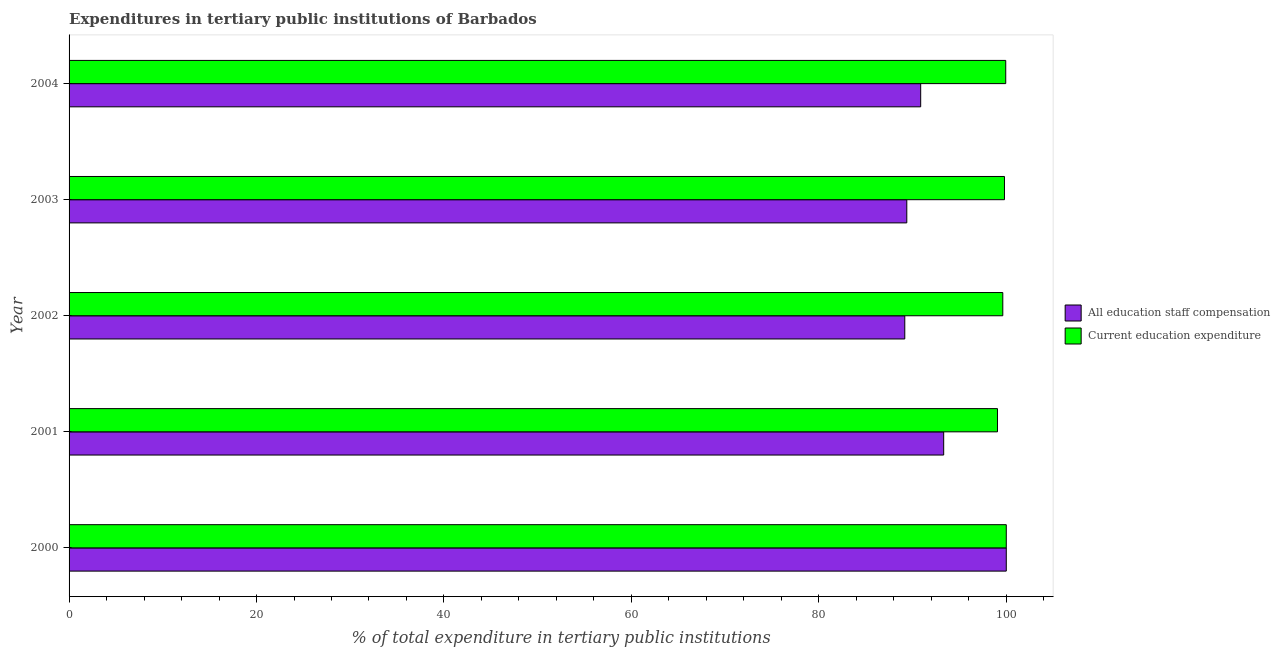How many groups of bars are there?
Make the answer very short. 5. Are the number of bars per tick equal to the number of legend labels?
Make the answer very short. Yes. How many bars are there on the 5th tick from the bottom?
Offer a very short reply. 2. What is the label of the 5th group of bars from the top?
Your response must be concise. 2000. In how many cases, is the number of bars for a given year not equal to the number of legend labels?
Ensure brevity in your answer.  0. What is the expenditure in education in 2000?
Make the answer very short. 100. Across all years, what is the minimum expenditure in staff compensation?
Keep it short and to the point. 89.17. What is the total expenditure in education in the graph?
Your response must be concise. 498.43. What is the difference between the expenditure in education in 2001 and that in 2003?
Ensure brevity in your answer.  -0.74. What is the difference between the expenditure in staff compensation in 2003 and the expenditure in education in 2001?
Your answer should be compact. -9.68. What is the average expenditure in staff compensation per year?
Your response must be concise. 92.55. In the year 2001, what is the difference between the expenditure in staff compensation and expenditure in education?
Give a very brief answer. -5.74. Is the difference between the expenditure in staff compensation in 2003 and 2004 greater than the difference between the expenditure in education in 2003 and 2004?
Offer a terse response. No. What is the difference between the highest and the second highest expenditure in education?
Offer a very short reply. 0.06. What is the difference between the highest and the lowest expenditure in staff compensation?
Your answer should be very brief. 10.83. Is the sum of the expenditure in staff compensation in 2000 and 2001 greater than the maximum expenditure in education across all years?
Your answer should be very brief. Yes. What does the 2nd bar from the top in 2004 represents?
Your answer should be compact. All education staff compensation. What does the 1st bar from the bottom in 2001 represents?
Your answer should be very brief. All education staff compensation. Are all the bars in the graph horizontal?
Provide a succinct answer. Yes. How many years are there in the graph?
Your answer should be very brief. 5. What is the difference between two consecutive major ticks on the X-axis?
Provide a succinct answer. 20. Does the graph contain grids?
Ensure brevity in your answer.  No. Where does the legend appear in the graph?
Provide a succinct answer. Center right. How many legend labels are there?
Your answer should be very brief. 2. How are the legend labels stacked?
Offer a very short reply. Vertical. What is the title of the graph?
Give a very brief answer. Expenditures in tertiary public institutions of Barbados. Does "Rural" appear as one of the legend labels in the graph?
Your response must be concise. No. What is the label or title of the X-axis?
Keep it short and to the point. % of total expenditure in tertiary public institutions. What is the % of total expenditure in tertiary public institutions in All education staff compensation in 2000?
Provide a succinct answer. 100. What is the % of total expenditure in tertiary public institutions in Current education expenditure in 2000?
Make the answer very short. 100. What is the % of total expenditure in tertiary public institutions of All education staff compensation in 2001?
Your answer should be compact. 93.32. What is the % of total expenditure in tertiary public institutions in Current education expenditure in 2001?
Give a very brief answer. 99.06. What is the % of total expenditure in tertiary public institutions in All education staff compensation in 2002?
Your answer should be very brief. 89.17. What is the % of total expenditure in tertiary public institutions in Current education expenditure in 2002?
Your answer should be very brief. 99.63. What is the % of total expenditure in tertiary public institutions of All education staff compensation in 2003?
Your answer should be very brief. 89.38. What is the % of total expenditure in tertiary public institutions of Current education expenditure in 2003?
Offer a very short reply. 99.81. What is the % of total expenditure in tertiary public institutions of All education staff compensation in 2004?
Give a very brief answer. 90.87. What is the % of total expenditure in tertiary public institutions in Current education expenditure in 2004?
Your response must be concise. 99.94. Across all years, what is the maximum % of total expenditure in tertiary public institutions of All education staff compensation?
Ensure brevity in your answer.  100. Across all years, what is the maximum % of total expenditure in tertiary public institutions of Current education expenditure?
Make the answer very short. 100. Across all years, what is the minimum % of total expenditure in tertiary public institutions in All education staff compensation?
Give a very brief answer. 89.17. Across all years, what is the minimum % of total expenditure in tertiary public institutions in Current education expenditure?
Your response must be concise. 99.06. What is the total % of total expenditure in tertiary public institutions of All education staff compensation in the graph?
Provide a succinct answer. 462.74. What is the total % of total expenditure in tertiary public institutions of Current education expenditure in the graph?
Provide a succinct answer. 498.44. What is the difference between the % of total expenditure in tertiary public institutions in All education staff compensation in 2000 and that in 2001?
Make the answer very short. 6.68. What is the difference between the % of total expenditure in tertiary public institutions of Current education expenditure in 2000 and that in 2001?
Your answer should be compact. 0.94. What is the difference between the % of total expenditure in tertiary public institutions of All education staff compensation in 2000 and that in 2002?
Make the answer very short. 10.83. What is the difference between the % of total expenditure in tertiary public institutions in Current education expenditure in 2000 and that in 2002?
Give a very brief answer. 0.37. What is the difference between the % of total expenditure in tertiary public institutions in All education staff compensation in 2000 and that in 2003?
Provide a succinct answer. 10.62. What is the difference between the % of total expenditure in tertiary public institutions in Current education expenditure in 2000 and that in 2003?
Offer a terse response. 0.19. What is the difference between the % of total expenditure in tertiary public institutions in All education staff compensation in 2000 and that in 2004?
Make the answer very short. 9.13. What is the difference between the % of total expenditure in tertiary public institutions of Current education expenditure in 2000 and that in 2004?
Your answer should be very brief. 0.06. What is the difference between the % of total expenditure in tertiary public institutions in All education staff compensation in 2001 and that in 2002?
Offer a terse response. 4.15. What is the difference between the % of total expenditure in tertiary public institutions of Current education expenditure in 2001 and that in 2002?
Provide a succinct answer. -0.57. What is the difference between the % of total expenditure in tertiary public institutions in All education staff compensation in 2001 and that in 2003?
Give a very brief answer. 3.94. What is the difference between the % of total expenditure in tertiary public institutions of Current education expenditure in 2001 and that in 2003?
Your answer should be compact. -0.75. What is the difference between the % of total expenditure in tertiary public institutions of All education staff compensation in 2001 and that in 2004?
Provide a succinct answer. 2.45. What is the difference between the % of total expenditure in tertiary public institutions in Current education expenditure in 2001 and that in 2004?
Keep it short and to the point. -0.88. What is the difference between the % of total expenditure in tertiary public institutions in All education staff compensation in 2002 and that in 2003?
Ensure brevity in your answer.  -0.21. What is the difference between the % of total expenditure in tertiary public institutions of Current education expenditure in 2002 and that in 2003?
Make the answer very short. -0.18. What is the difference between the % of total expenditure in tertiary public institutions of All education staff compensation in 2002 and that in 2004?
Your response must be concise. -1.7. What is the difference between the % of total expenditure in tertiary public institutions of Current education expenditure in 2002 and that in 2004?
Your answer should be compact. -0.31. What is the difference between the % of total expenditure in tertiary public institutions of All education staff compensation in 2003 and that in 2004?
Your response must be concise. -1.48. What is the difference between the % of total expenditure in tertiary public institutions of Current education expenditure in 2003 and that in 2004?
Offer a terse response. -0.13. What is the difference between the % of total expenditure in tertiary public institutions of All education staff compensation in 2000 and the % of total expenditure in tertiary public institutions of Current education expenditure in 2001?
Offer a terse response. 0.94. What is the difference between the % of total expenditure in tertiary public institutions in All education staff compensation in 2000 and the % of total expenditure in tertiary public institutions in Current education expenditure in 2002?
Your answer should be very brief. 0.37. What is the difference between the % of total expenditure in tertiary public institutions of All education staff compensation in 2000 and the % of total expenditure in tertiary public institutions of Current education expenditure in 2003?
Provide a succinct answer. 0.19. What is the difference between the % of total expenditure in tertiary public institutions in All education staff compensation in 2000 and the % of total expenditure in tertiary public institutions in Current education expenditure in 2004?
Your answer should be very brief. 0.06. What is the difference between the % of total expenditure in tertiary public institutions in All education staff compensation in 2001 and the % of total expenditure in tertiary public institutions in Current education expenditure in 2002?
Ensure brevity in your answer.  -6.31. What is the difference between the % of total expenditure in tertiary public institutions of All education staff compensation in 2001 and the % of total expenditure in tertiary public institutions of Current education expenditure in 2003?
Keep it short and to the point. -6.49. What is the difference between the % of total expenditure in tertiary public institutions of All education staff compensation in 2001 and the % of total expenditure in tertiary public institutions of Current education expenditure in 2004?
Offer a very short reply. -6.62. What is the difference between the % of total expenditure in tertiary public institutions of All education staff compensation in 2002 and the % of total expenditure in tertiary public institutions of Current education expenditure in 2003?
Your answer should be compact. -10.64. What is the difference between the % of total expenditure in tertiary public institutions of All education staff compensation in 2002 and the % of total expenditure in tertiary public institutions of Current education expenditure in 2004?
Your response must be concise. -10.77. What is the difference between the % of total expenditure in tertiary public institutions in All education staff compensation in 2003 and the % of total expenditure in tertiary public institutions in Current education expenditure in 2004?
Your answer should be compact. -10.56. What is the average % of total expenditure in tertiary public institutions of All education staff compensation per year?
Provide a succinct answer. 92.55. What is the average % of total expenditure in tertiary public institutions of Current education expenditure per year?
Ensure brevity in your answer.  99.69. In the year 2000, what is the difference between the % of total expenditure in tertiary public institutions in All education staff compensation and % of total expenditure in tertiary public institutions in Current education expenditure?
Your response must be concise. 0. In the year 2001, what is the difference between the % of total expenditure in tertiary public institutions in All education staff compensation and % of total expenditure in tertiary public institutions in Current education expenditure?
Give a very brief answer. -5.74. In the year 2002, what is the difference between the % of total expenditure in tertiary public institutions in All education staff compensation and % of total expenditure in tertiary public institutions in Current education expenditure?
Ensure brevity in your answer.  -10.46. In the year 2003, what is the difference between the % of total expenditure in tertiary public institutions of All education staff compensation and % of total expenditure in tertiary public institutions of Current education expenditure?
Provide a short and direct response. -10.42. In the year 2004, what is the difference between the % of total expenditure in tertiary public institutions of All education staff compensation and % of total expenditure in tertiary public institutions of Current education expenditure?
Your answer should be very brief. -9.07. What is the ratio of the % of total expenditure in tertiary public institutions of All education staff compensation in 2000 to that in 2001?
Keep it short and to the point. 1.07. What is the ratio of the % of total expenditure in tertiary public institutions of Current education expenditure in 2000 to that in 2001?
Offer a terse response. 1.01. What is the ratio of the % of total expenditure in tertiary public institutions in All education staff compensation in 2000 to that in 2002?
Ensure brevity in your answer.  1.12. What is the ratio of the % of total expenditure in tertiary public institutions of All education staff compensation in 2000 to that in 2003?
Ensure brevity in your answer.  1.12. What is the ratio of the % of total expenditure in tertiary public institutions in All education staff compensation in 2000 to that in 2004?
Offer a very short reply. 1.1. What is the ratio of the % of total expenditure in tertiary public institutions of All education staff compensation in 2001 to that in 2002?
Your answer should be very brief. 1.05. What is the ratio of the % of total expenditure in tertiary public institutions of All education staff compensation in 2001 to that in 2003?
Keep it short and to the point. 1.04. What is the ratio of the % of total expenditure in tertiary public institutions of All education staff compensation in 2001 to that in 2004?
Ensure brevity in your answer.  1.03. What is the ratio of the % of total expenditure in tertiary public institutions in Current education expenditure in 2001 to that in 2004?
Offer a terse response. 0.99. What is the ratio of the % of total expenditure in tertiary public institutions in Current education expenditure in 2002 to that in 2003?
Your answer should be very brief. 1. What is the ratio of the % of total expenditure in tertiary public institutions in All education staff compensation in 2002 to that in 2004?
Make the answer very short. 0.98. What is the ratio of the % of total expenditure in tertiary public institutions in All education staff compensation in 2003 to that in 2004?
Provide a short and direct response. 0.98. What is the ratio of the % of total expenditure in tertiary public institutions in Current education expenditure in 2003 to that in 2004?
Provide a succinct answer. 1. What is the difference between the highest and the second highest % of total expenditure in tertiary public institutions in All education staff compensation?
Your response must be concise. 6.68. What is the difference between the highest and the second highest % of total expenditure in tertiary public institutions of Current education expenditure?
Offer a terse response. 0.06. What is the difference between the highest and the lowest % of total expenditure in tertiary public institutions in All education staff compensation?
Your answer should be very brief. 10.83. What is the difference between the highest and the lowest % of total expenditure in tertiary public institutions in Current education expenditure?
Keep it short and to the point. 0.94. 